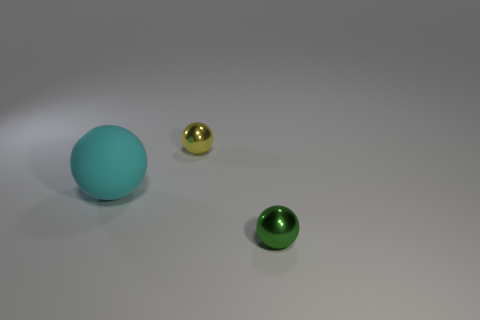Add 1 tiny yellow metallic balls. How many objects exist? 4 Add 2 green metallic things. How many green metallic things exist? 3 Subtract 1 green balls. How many objects are left? 2 Subtract all red matte blocks. Subtract all large things. How many objects are left? 2 Add 1 green spheres. How many green spheres are left? 2 